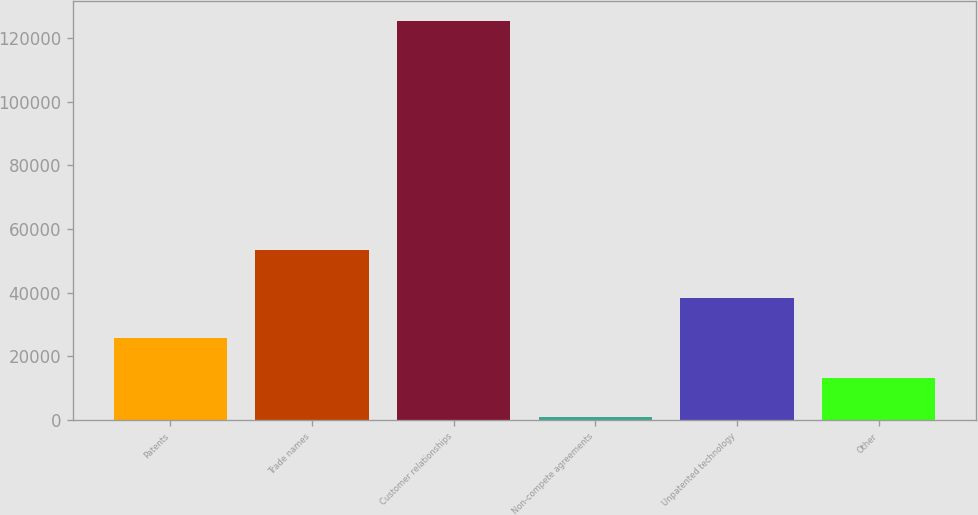<chart> <loc_0><loc_0><loc_500><loc_500><bar_chart><fcel>Patents<fcel>Trade names<fcel>Customer relationships<fcel>Non-compete agreements<fcel>Unpatented technology<fcel>Other<nl><fcel>25823.2<fcel>53445<fcel>125468<fcel>912<fcel>38278.8<fcel>13367.6<nl></chart> 